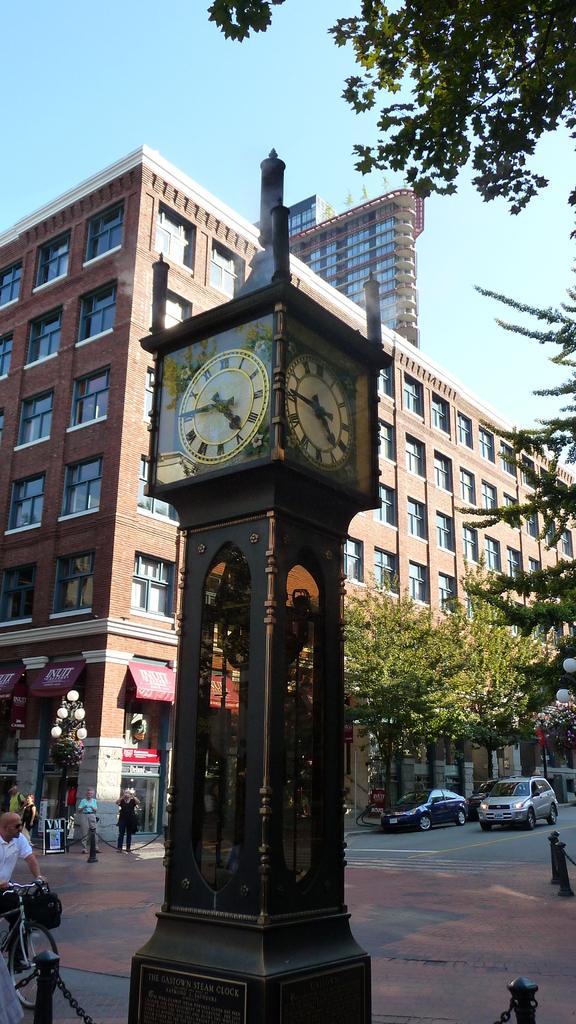In one or two sentences, can you explain what this image depicts? At the top there is a sky. We can see a building. This is a clock tower. We can see trees and vehicles near to the building. We can also see people standing. On the left side of the picture we can see a man wearing a white t-shirt and riding a bicycle. 